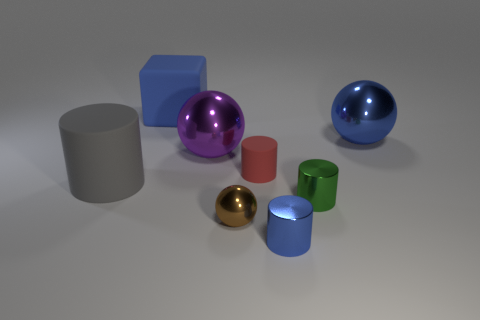Add 4 big purple things. How many big purple things are left? 5 Add 1 tiny green metallic spheres. How many tiny green metallic spheres exist? 1 Add 1 rubber cubes. How many objects exist? 9 Subtract all green cylinders. How many cylinders are left? 3 Subtract all tiny cylinders. How many cylinders are left? 1 Subtract 0 red spheres. How many objects are left? 8 Subtract all spheres. How many objects are left? 5 Subtract 1 cubes. How many cubes are left? 0 Subtract all yellow spheres. Subtract all yellow blocks. How many spheres are left? 3 Subtract all purple cylinders. How many gray cubes are left? 0 